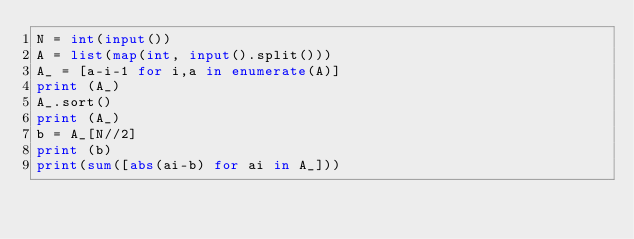Convert code to text. <code><loc_0><loc_0><loc_500><loc_500><_Python_>N = int(input())
A = list(map(int, input().split()))
A_ = [a-i-1 for i,a in enumerate(A)]
print (A_)
A_.sort()
print (A_)
b = A_[N//2]
print (b)
print(sum([abs(ai-b) for ai in A_]))</code> 